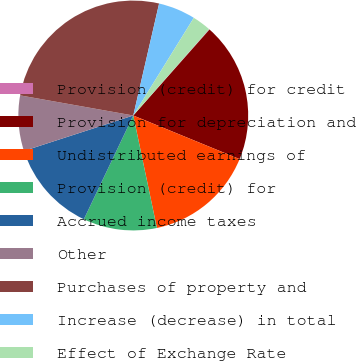Convert chart. <chart><loc_0><loc_0><loc_500><loc_500><pie_chart><fcel>Provision (credit) for credit<fcel>Provision for depreciation and<fcel>Undistributed earnings of<fcel>Provision (credit) for<fcel>Accrued income taxes<fcel>Other<fcel>Purchases of property and<fcel>Increase (decrease) in total<fcel>Effect of Exchange Rate<nl><fcel>0.07%<fcel>19.65%<fcel>15.51%<fcel>10.37%<fcel>12.94%<fcel>7.79%<fcel>25.81%<fcel>5.22%<fcel>2.65%<nl></chart> 